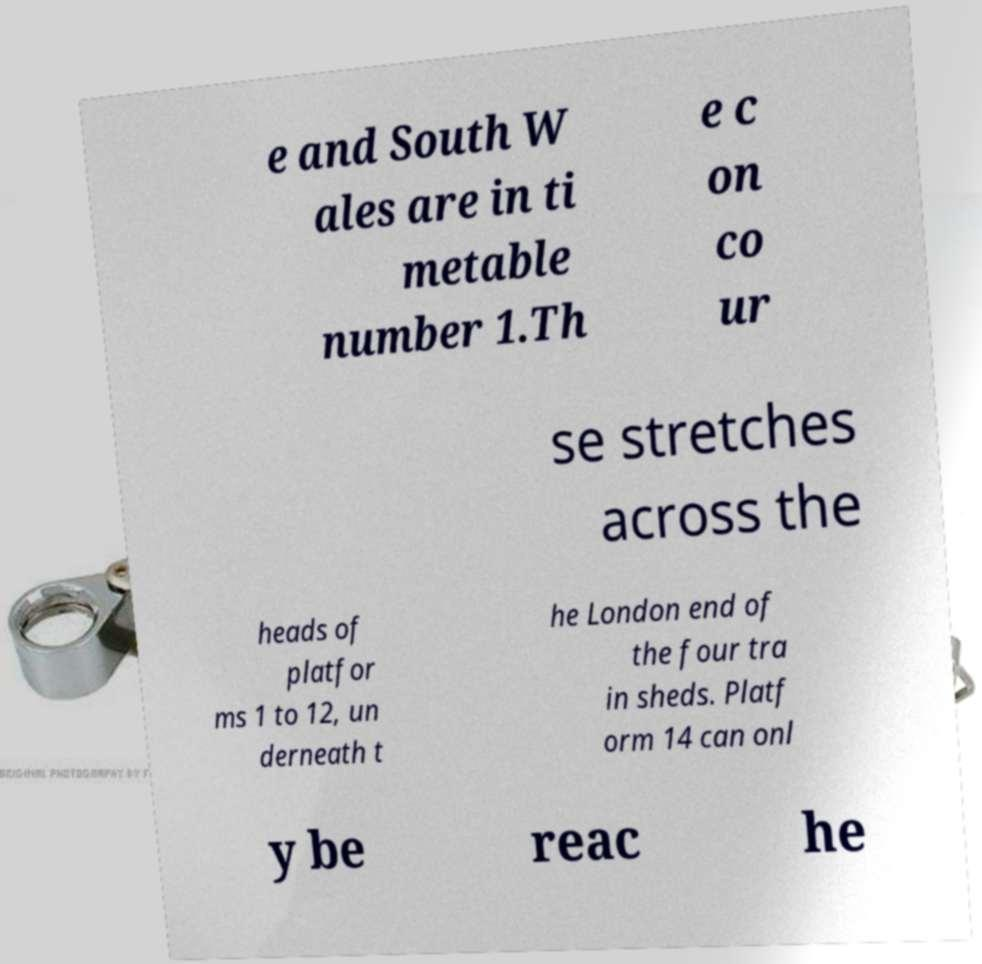What messages or text are displayed in this image? I need them in a readable, typed format. e and South W ales are in ti metable number 1.Th e c on co ur se stretches across the heads of platfor ms 1 to 12, un derneath t he London end of the four tra in sheds. Platf orm 14 can onl y be reac he 